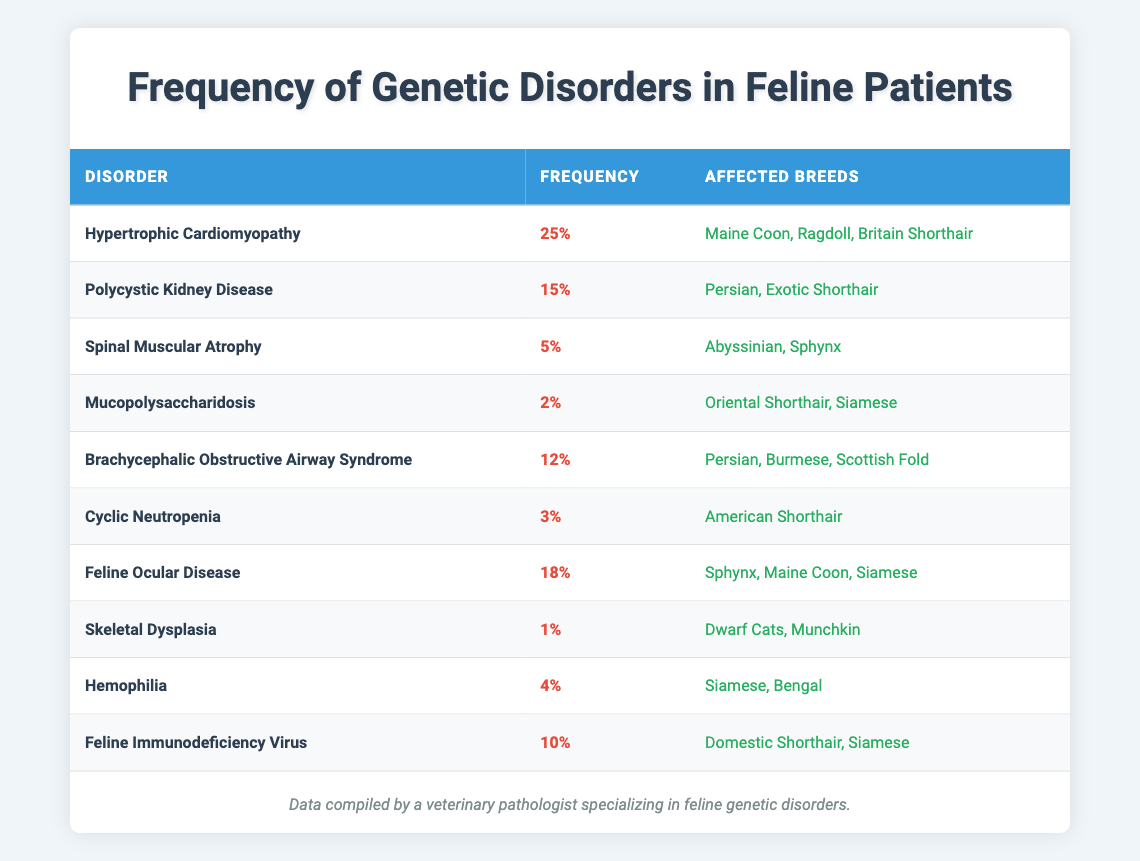What is the most common genetic disorder among feline patients? The table lists "Hypertrophic Cardiomyopathy" as the disorder with the highest frequency of 0.25 (or 25%), making it the most common.
Answer: Hypertrophic Cardiomyopathy Which breeds are affected by Polycystic Kidney Disease? The table shows that "Persian" and "Exotic Shorthair" breeds are affected by Polycystic Kidney Disease.
Answer: Persian, Exotic Shorthair What is the average frequency of the genetic disorders listed in the table? The frequencies given in the table can be summed: 0.25 + 0.15 + 0.05 + 0.02 + 0.12 + 0.03 + 0.18 + 0.01 + 0.04 + 0.10 = 0.725. There are 10 disorders, so the average frequency is 0.725 / 10 = 0.0725 or 7.25%.
Answer: 7.25% Is Brachycephalic Obstructive Airway Syndrome more common than Skeletal Dysplasia? Brachycephalic Obstructive Airway Syndrome has a frequency of 0.12 (12%), while Skeletal Dysplasia has a frequency of 0.01 (1%). 12% is greater than 1%, so the statement is true.
Answer: Yes Which disorder affects the least number of breeds? By examining the table, "Skeletal Dysplasia" affects only two breeds ("Dwarf Cats" and "Munchkin"), which is fewer than any other disorder.
Answer: Skeletal Dysplasia How many disorders have a frequency of less than 5%? The disorders with frequencies less than 5% are "Spinal Muscular Atrophy" (0.05), "Mucopolysaccharidosis" (0.02), "Cyclic Neutropenia" (0.03), "Skeletal Dysplasia" (0.01), and "Hemophilia" (0.04). This counts to 5 disorders.
Answer: 5 Is Feline Ocular Disease more prevalent than Feline Immunodeficiency Virus? Feline Ocular Disease has a frequency of 0.18 (18%), while Feline Immunodeficiency Virus has a frequency of 0.10 (10%). Since 18% is greater than 10%, the statement is true.
Answer: Yes Which disorder has the same frequency as Hemophilia? The table indicates that no other disorder shares the same frequency as Hemophilia (0.04). Therefore, Hemophilia is unique at that frequency.
Answer: None What fraction of the disorders affect the Siamese breed? The disorders affecting the Siamese breed are Hypertrophic Cardiomyopathy, Feline Ocular Disease, Hemophilia, Mucopolysaccharidosis, and Feline Immunodeficiency Virus, totaling 5 disorders. Since there are 10 disorders listed, the fraction is 5/10, which simplifies to 1/2.
Answer: 1/2 Which two genetic disorders have the highest frequency combined? The two highest frequency disorders are "Hypertrophic Cardiomyopathy" (0.25) and "Feline Ocular Disease" (0.18). Their combined frequency is 0.25 + 0.18 = 0.43 (or 43%).
Answer: 43% 